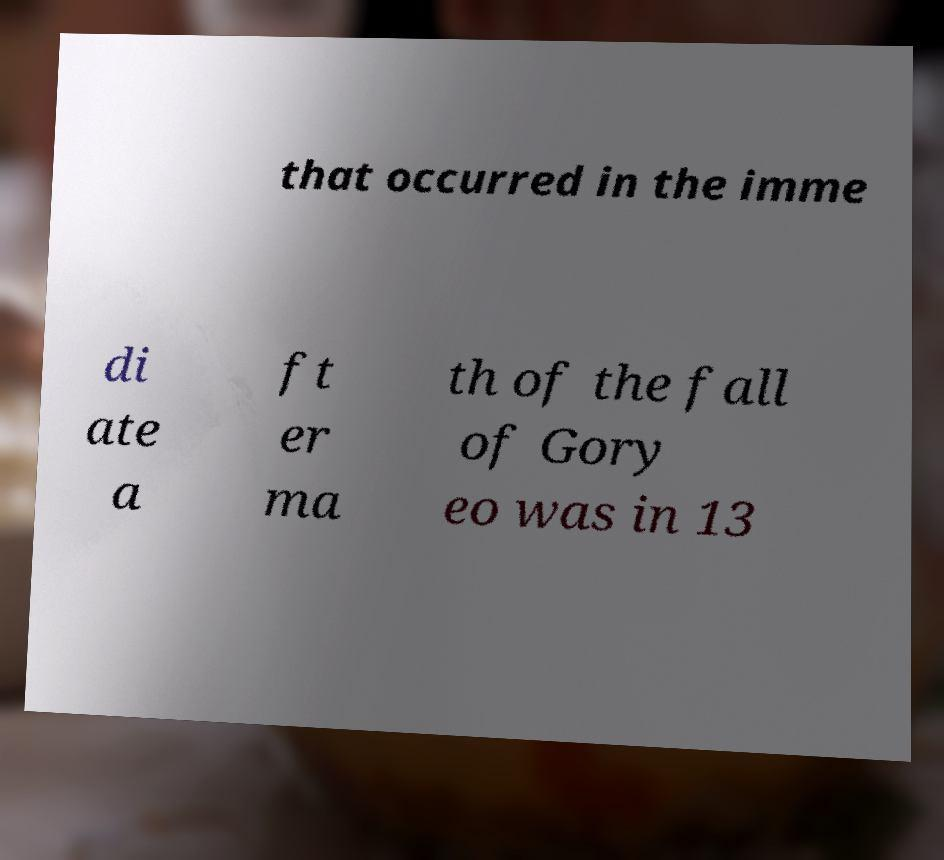Could you extract and type out the text from this image? that occurred in the imme di ate a ft er ma th of the fall of Gory eo was in 13 